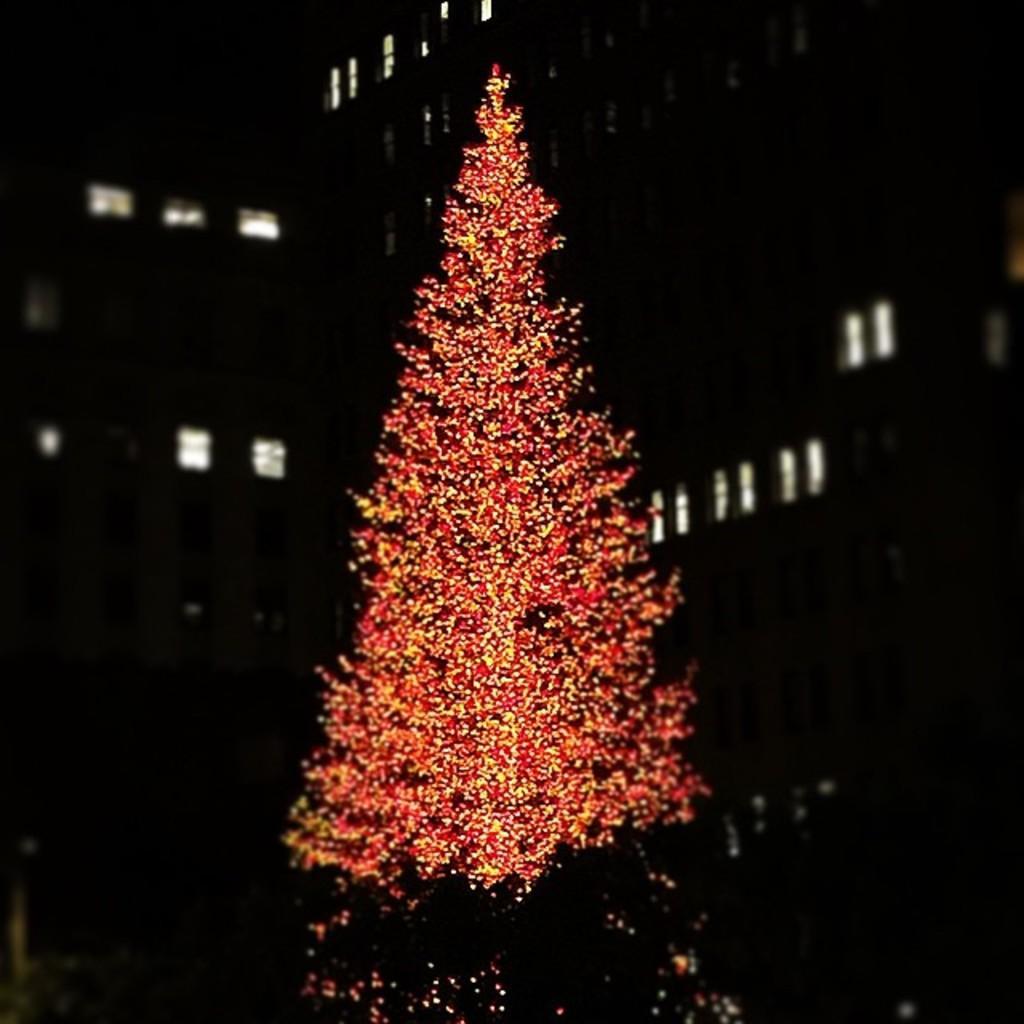Please provide a concise description of this image. In this image I can see a red colour tree over here and In the background I can see lights. I can also see this image is little bit in dark from background. 